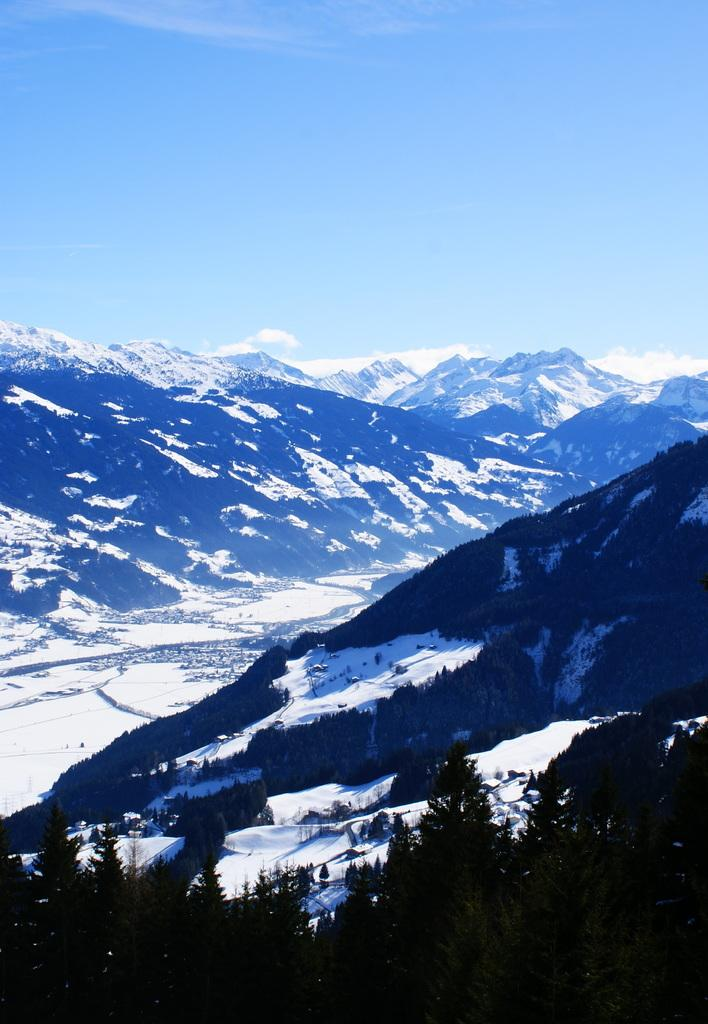What type of vegetation is at the bottom of the image? There are trees at the bottom of the image. What is the weather like in the image? There is snow visible in the background of the image, indicating a cold or wintery environment. What can be seen in the distance in the image? There are objects, mountains, and clouds in the background of the image. How many snails can be seen crawling on the trees in the image? There are no snails visible in the image; it features trees, snow, and a mountainous background. What type of pen is used to draw the clouds in the image? There is no pen or drawing involved in the image; it is a photograph of a snowy landscape with clouds in the sky. 